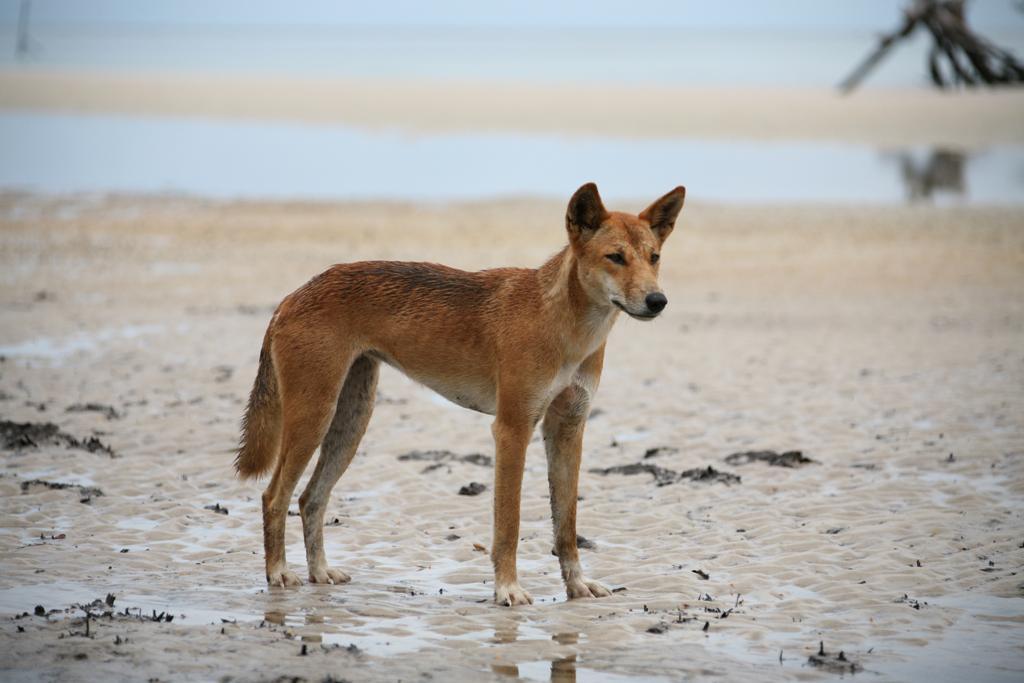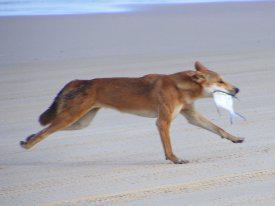The first image is the image on the left, the second image is the image on the right. Considering the images on both sides, is "A dog is at the left of an image, standing behind a dead animal washed up on a beach." valid? Answer yes or no. No. The first image is the image on the left, the second image is the image on the right. Given the left and right images, does the statement "The dingo's body in the left image is facing towards the left." hold true? Answer yes or no. No. 